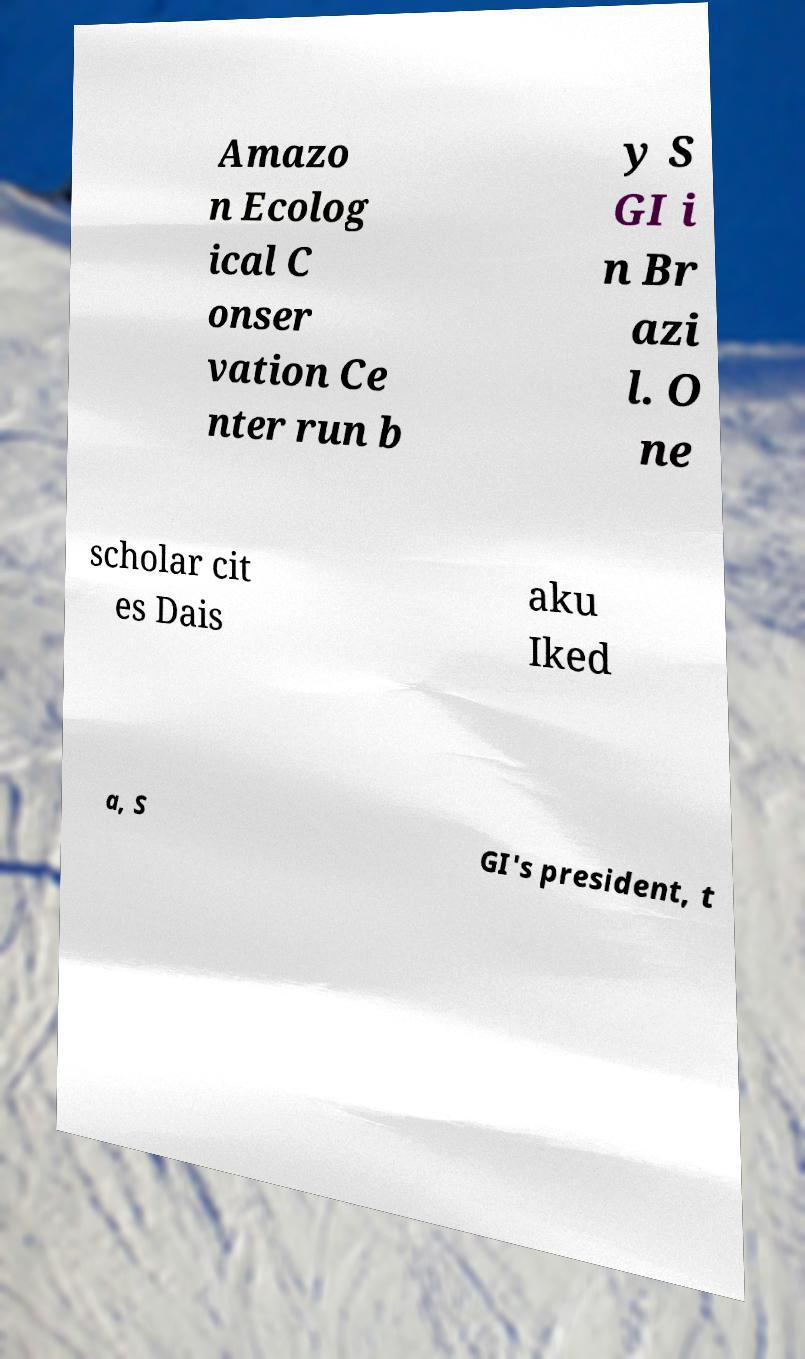Please identify and transcribe the text found in this image. Amazo n Ecolog ical C onser vation Ce nter run b y S GI i n Br azi l. O ne scholar cit es Dais aku Iked a, S GI's president, t 